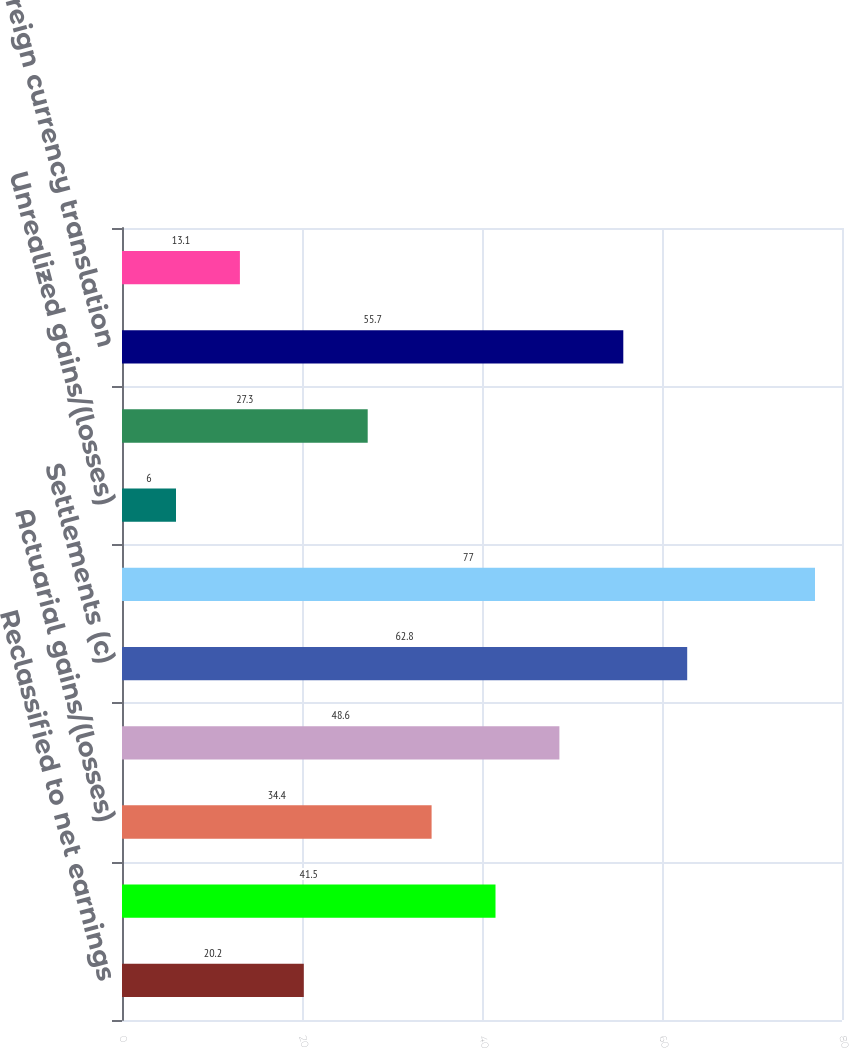Convert chart to OTSL. <chart><loc_0><loc_0><loc_500><loc_500><bar_chart><fcel>Reclassified to net earnings<fcel>Derivatives qualifying as cash<fcel>Actuarial gains/(losses)<fcel>Amortization (b)<fcel>Settlements (c)<fcel>Pension and postretirement<fcel>Unrealized gains/(losses)<fcel>Available-for-sale securities<fcel>Foreign currency translation<fcel>Total Other Comprehensive<nl><fcel>20.2<fcel>41.5<fcel>34.4<fcel>48.6<fcel>62.8<fcel>77<fcel>6<fcel>27.3<fcel>55.7<fcel>13.1<nl></chart> 